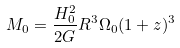Convert formula to latex. <formula><loc_0><loc_0><loc_500><loc_500>M _ { 0 } = \frac { H _ { 0 } ^ { 2 } } { 2 G } R ^ { 3 } \Omega _ { 0 } ( 1 + z ) ^ { 3 }</formula> 